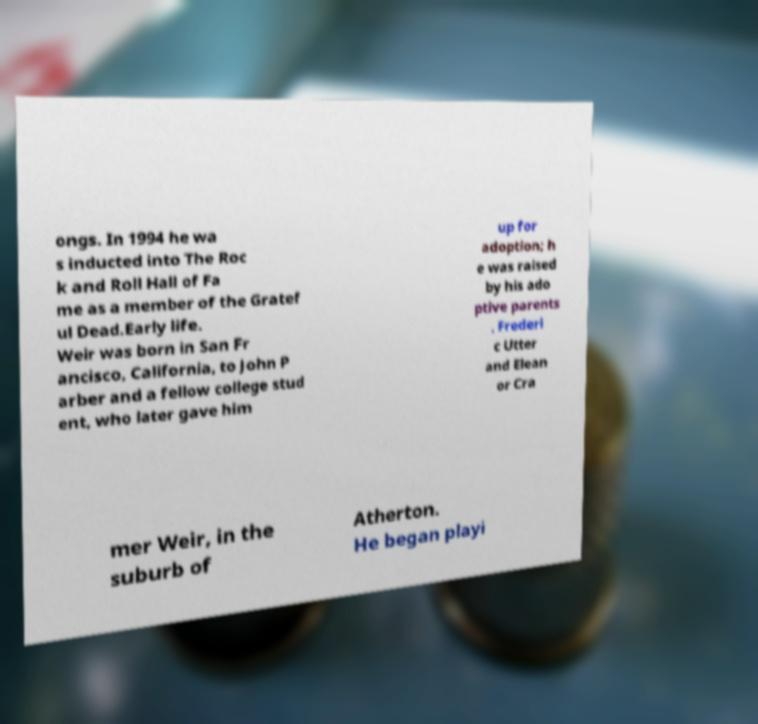Could you assist in decoding the text presented in this image and type it out clearly? ongs. In 1994 he wa s inducted into The Roc k and Roll Hall of Fa me as a member of the Gratef ul Dead.Early life. Weir was born in San Fr ancisco, California, to John P arber and a fellow college stud ent, who later gave him up for adoption; h e was raised by his ado ptive parents , Frederi c Utter and Elean or Cra mer Weir, in the suburb of Atherton. He began playi 